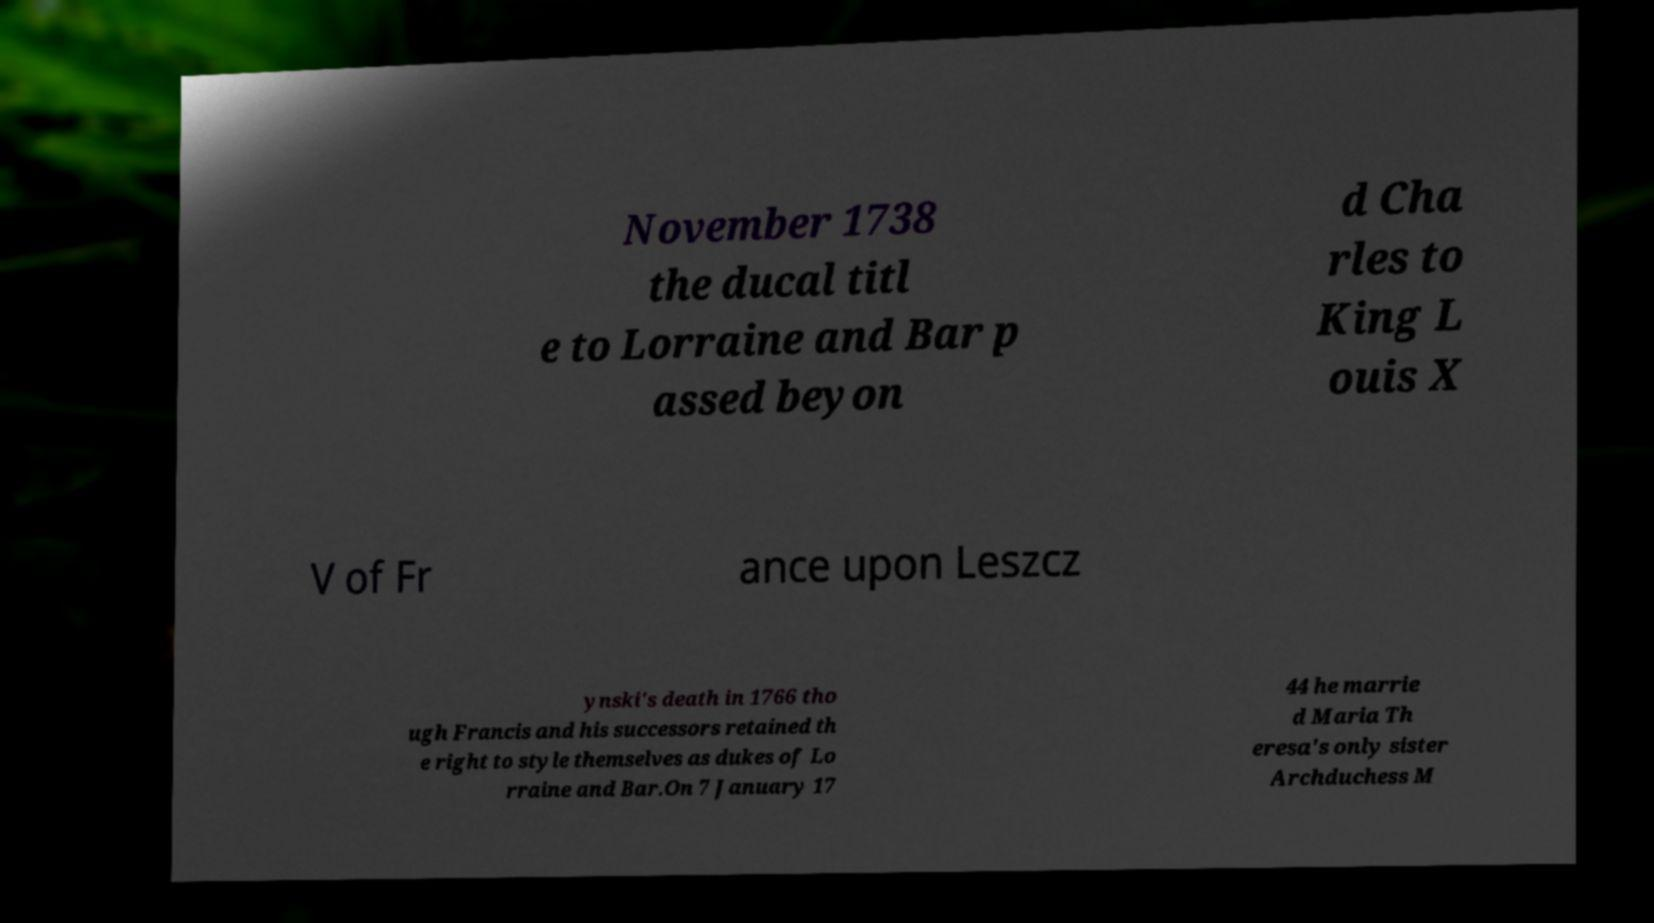I need the written content from this picture converted into text. Can you do that? November 1738 the ducal titl e to Lorraine and Bar p assed beyon d Cha rles to King L ouis X V of Fr ance upon Leszcz ynski's death in 1766 tho ugh Francis and his successors retained th e right to style themselves as dukes of Lo rraine and Bar.On 7 January 17 44 he marrie d Maria Th eresa's only sister Archduchess M 